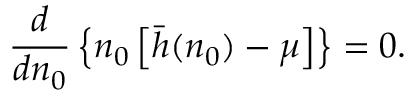<formula> <loc_0><loc_0><loc_500><loc_500>\frac { d } d n _ { 0 } } \left \{ n _ { 0 } \left [ \bar { h } ( n _ { 0 } ) - \mu \right ] \right \} = 0 .</formula> 